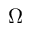<formula> <loc_0><loc_0><loc_500><loc_500>\Omega</formula> 